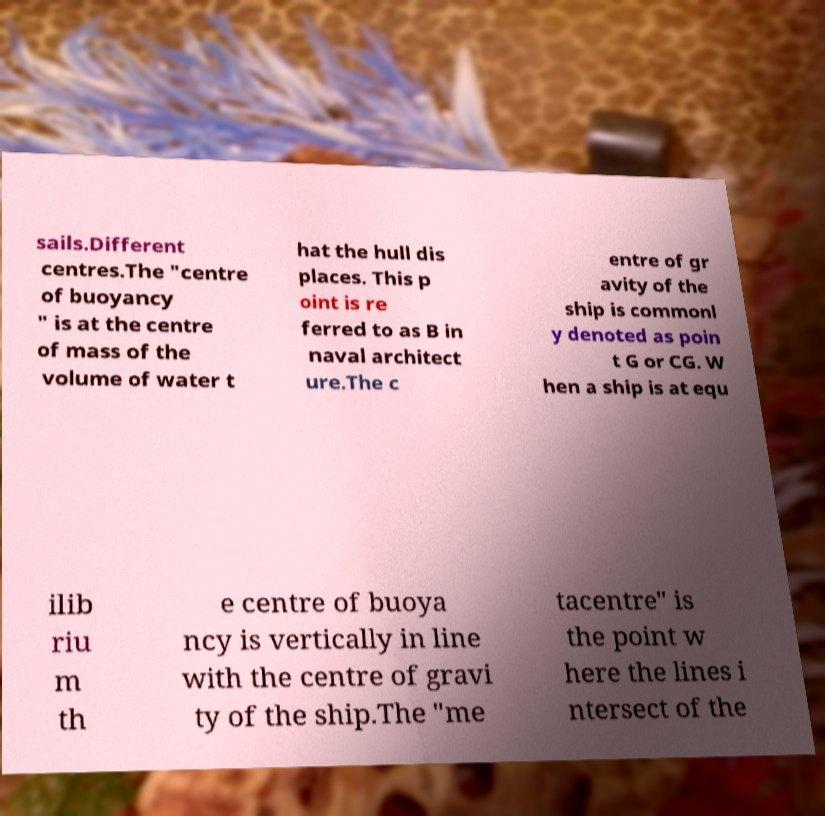What messages or text are displayed in this image? I need them in a readable, typed format. sails.Different centres.The "centre of buoyancy " is at the centre of mass of the volume of water t hat the hull dis places. This p oint is re ferred to as B in naval architect ure.The c entre of gr avity of the ship is commonl y denoted as poin t G or CG. W hen a ship is at equ ilib riu m th e centre of buoya ncy is vertically in line with the centre of gravi ty of the ship.The "me tacentre" is the point w here the lines i ntersect of the 